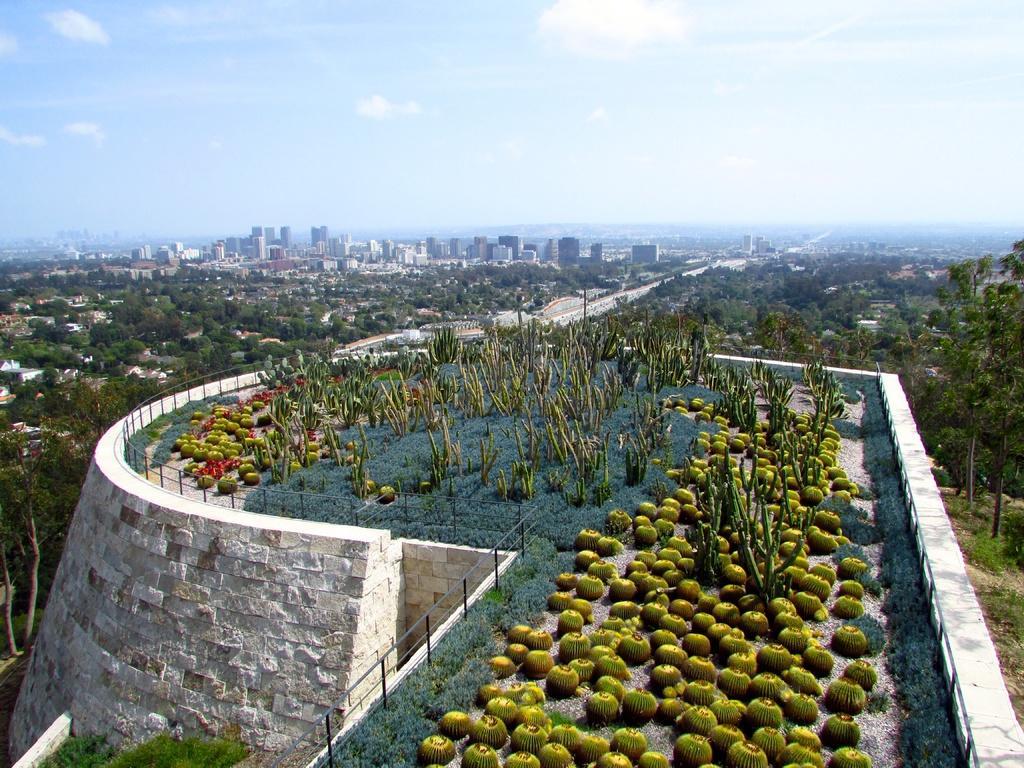Describe this image in one or two sentences. At the bottom of the picture, we see plants, grass and fruits. Beside that, we see the railing. Beside that, we see a wall which is made up of stones. There are trees and buildings in the background. At the top, we see the sky and the clouds. 